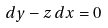Convert formula to latex. <formula><loc_0><loc_0><loc_500><loc_500>d y - z \, d x = 0</formula> 